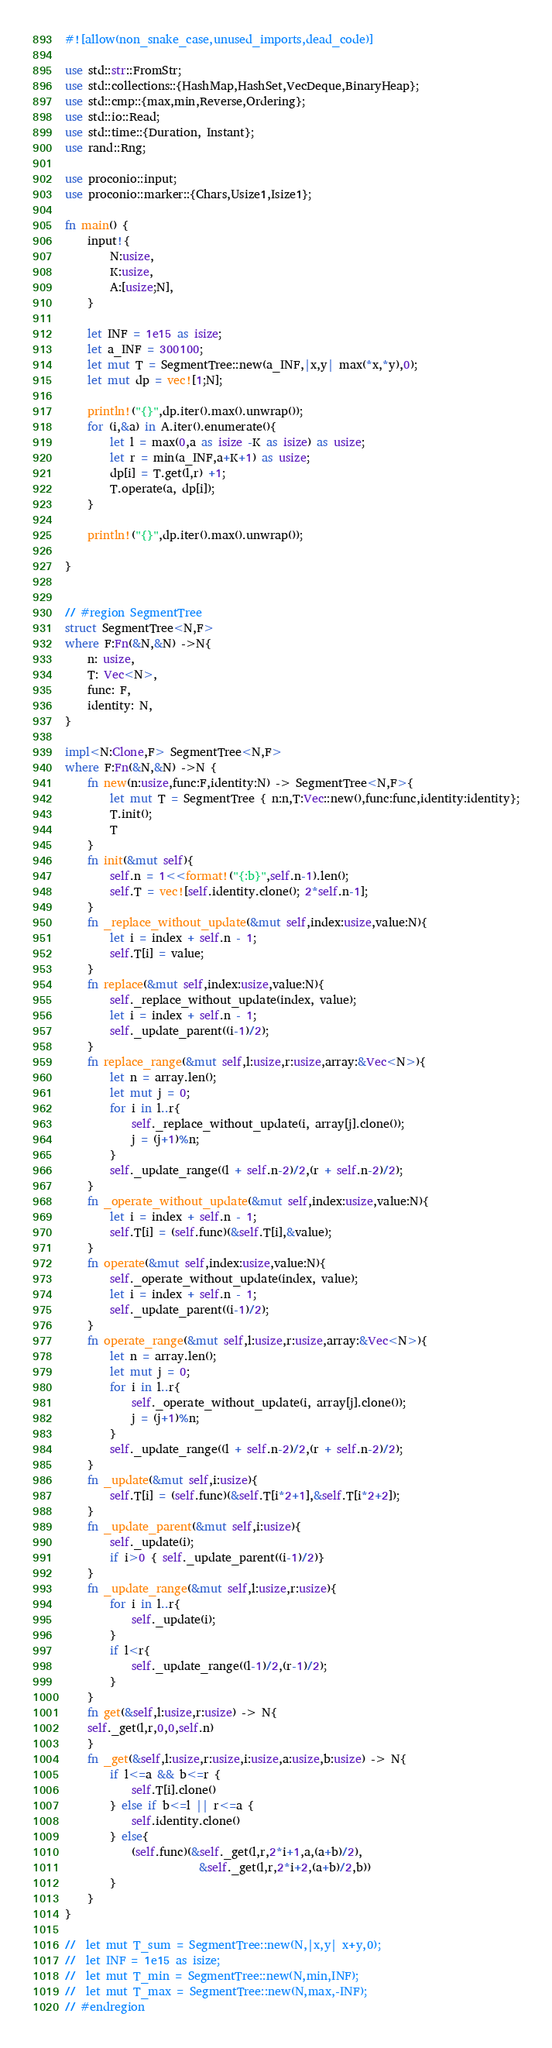Convert code to text. <code><loc_0><loc_0><loc_500><loc_500><_Rust_>#![allow(non_snake_case,unused_imports,dead_code)]

use std::str::FromStr;
use std::collections::{HashMap,HashSet,VecDeque,BinaryHeap};
use std::cmp::{max,min,Reverse,Ordering};
use std::io::Read;
use std::time::{Duration, Instant};
use rand::Rng;
 
use proconio::input;
use proconio::marker::{Chars,Usize1,Isize1};

fn main() {
    input!{
        N:usize,
        K:usize,
        A:[usize;N],
    }

    let INF = 1e15 as isize;
    let a_INF = 300100;
    let mut T = SegmentTree::new(a_INF,|x,y| max(*x,*y),0);
    let mut dp = vec![1;N];

    println!("{}",dp.iter().max().unwrap());
    for (i,&a) in A.iter().enumerate(){
        let l = max(0,a as isize -K as isize) as usize;
        let r = min(a_INF,a+K+1) as usize;
        dp[i] = T.get(l,r) +1;
        T.operate(a, dp[i]);
    }

    println!("{}",dp.iter().max().unwrap());

}


// #region SegmentTree
struct SegmentTree<N,F>
where F:Fn(&N,&N) ->N{
    n: usize,
    T: Vec<N>,
    func: F,
    identity: N,
}

impl<N:Clone,F> SegmentTree<N,F>
where F:Fn(&N,&N) ->N {
    fn new(n:usize,func:F,identity:N) -> SegmentTree<N,F>{
        let mut T = SegmentTree { n:n,T:Vec::new(),func:func,identity:identity};
        T.init();
        T
    }
    fn init(&mut self){
        self.n = 1<<format!("{:b}",self.n-1).len();
        self.T = vec![self.identity.clone(); 2*self.n-1];
    }
    fn _replace_without_update(&mut self,index:usize,value:N){
        let i = index + self.n - 1;
        self.T[i] = value;
    }
    fn replace(&mut self,index:usize,value:N){
        self._replace_without_update(index, value);
        let i = index + self.n - 1;
        self._update_parent((i-1)/2);
    }
    fn replace_range(&mut self,l:usize,r:usize,array:&Vec<N>){
        let n = array.len();
        let mut j = 0;
        for i in l..r{
            self._replace_without_update(i, array[j].clone());
            j = (j+1)%n;
        }
        self._update_range((l + self.n-2)/2,(r + self.n-2)/2);
    }
    fn _operate_without_update(&mut self,index:usize,value:N){
        let i = index + self.n - 1;
        self.T[i] = (self.func)(&self.T[i],&value);
    }
    fn operate(&mut self,index:usize,value:N){
        self._operate_without_update(index, value);
        let i = index + self.n - 1;
        self._update_parent((i-1)/2);
    }
    fn operate_range(&mut self,l:usize,r:usize,array:&Vec<N>){
        let n = array.len();
        let mut j = 0;
        for i in l..r{
            self._operate_without_update(i, array[j].clone());
            j = (j+1)%n;
        }
        self._update_range((l + self.n-2)/2,(r + self.n-2)/2);
    }
    fn _update(&mut self,i:usize){
        self.T[i] = (self.func)(&self.T[i*2+1],&self.T[i*2+2]);
    }
    fn _update_parent(&mut self,i:usize){
        self._update(i);
        if i>0 { self._update_parent((i-1)/2)}
    }
    fn _update_range(&mut self,l:usize,r:usize){
        for i in l..r{
            self._update(i);
        }
        if l<r{
            self._update_range((l-1)/2,(r-1)/2);
        }
    }
    fn get(&self,l:usize,r:usize) -> N{
    self._get(l,r,0,0,self.n)
    }
    fn _get(&self,l:usize,r:usize,i:usize,a:usize,b:usize) -> N{
        if l<=a && b<=r {
            self.T[i].clone()
        } else if b<=l || r<=a {
            self.identity.clone()
        } else{
            (self.func)(&self._get(l,r,2*i+1,a,(a+b)/2),
                        &self._get(l,r,2*i+2,(a+b)/2,b))
        }
    }
}

//  let mut T_sum = SegmentTree::new(N,|x,y| x+y,0);
//  let INF = 1e15 as isize;
//  let mut T_min = SegmentTree::new(N,min,INF);
//  let mut T_max = SegmentTree::new(N,max,-INF);
// #endregion
</code> 